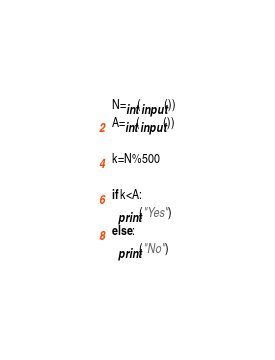Convert code to text. <code><loc_0><loc_0><loc_500><loc_500><_Python_>N=int(input())
A=int(input())

k=N%500

if k<A:
  print("Yes")
else:
  print("No")</code> 